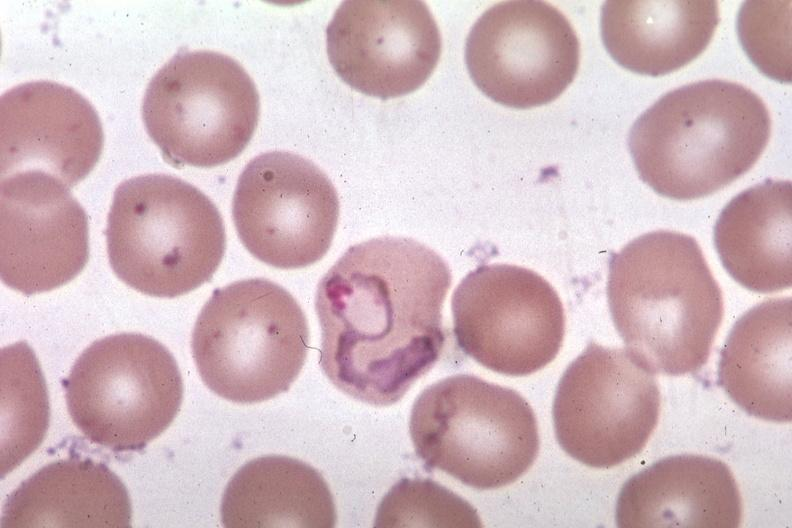what is present?
Answer the question using a single word or phrase. Hematologic 